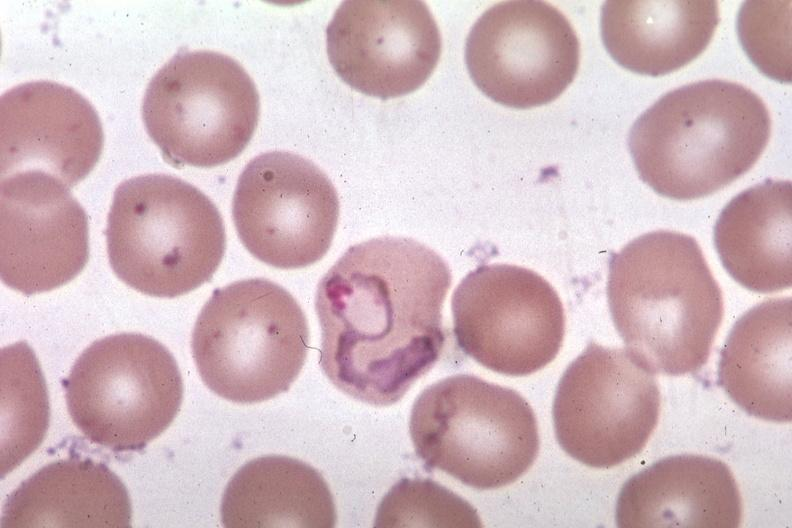what is present?
Answer the question using a single word or phrase. Hematologic 